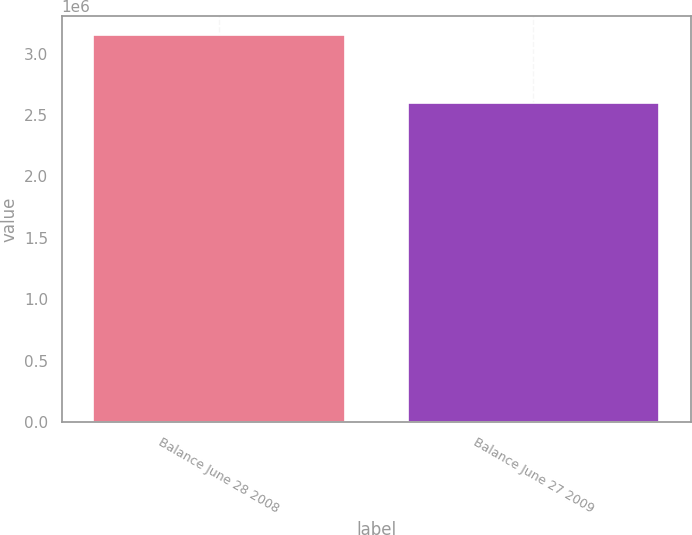<chart> <loc_0><loc_0><loc_500><loc_500><bar_chart><fcel>Balance June 28 2008<fcel>Balance June 27 2009<nl><fcel>3.14781e+06<fcel>2.59446e+06<nl></chart> 